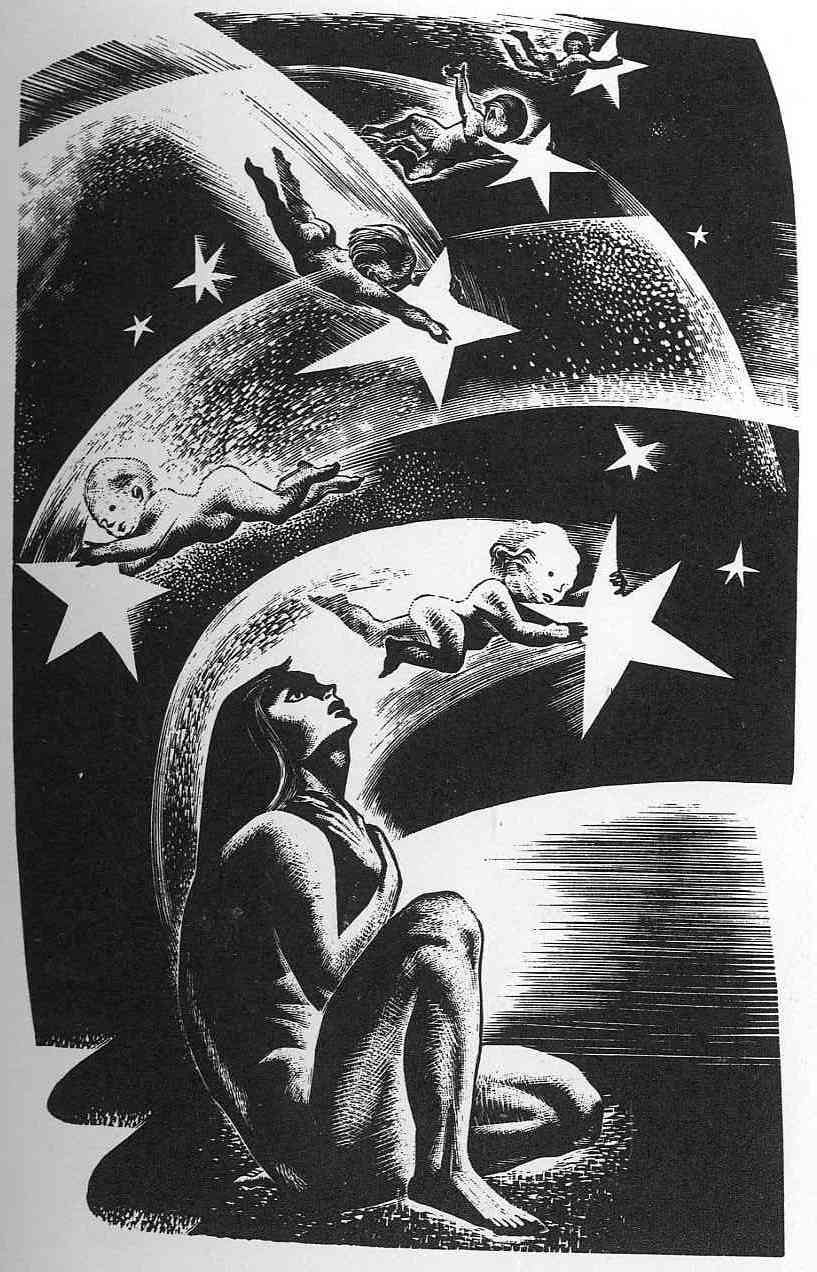Describe the artistic style and techniques used in this illustration. What effects do these techniques create? The artistic style of the illustration is deeply rooted in surrealist and expressionist influences, utilizing exaggerated and imaginative elements that defy conventional interpretation. Techniques such as bold linework and high contrast create a dynamic interplay of light and shadow, emphasizing the fluidity and ethereal quality of the scene. The textural depth achieved through varied line densities adds a tactile element that draws viewers into the artwork, making the celestial elements appear almost tangible. 